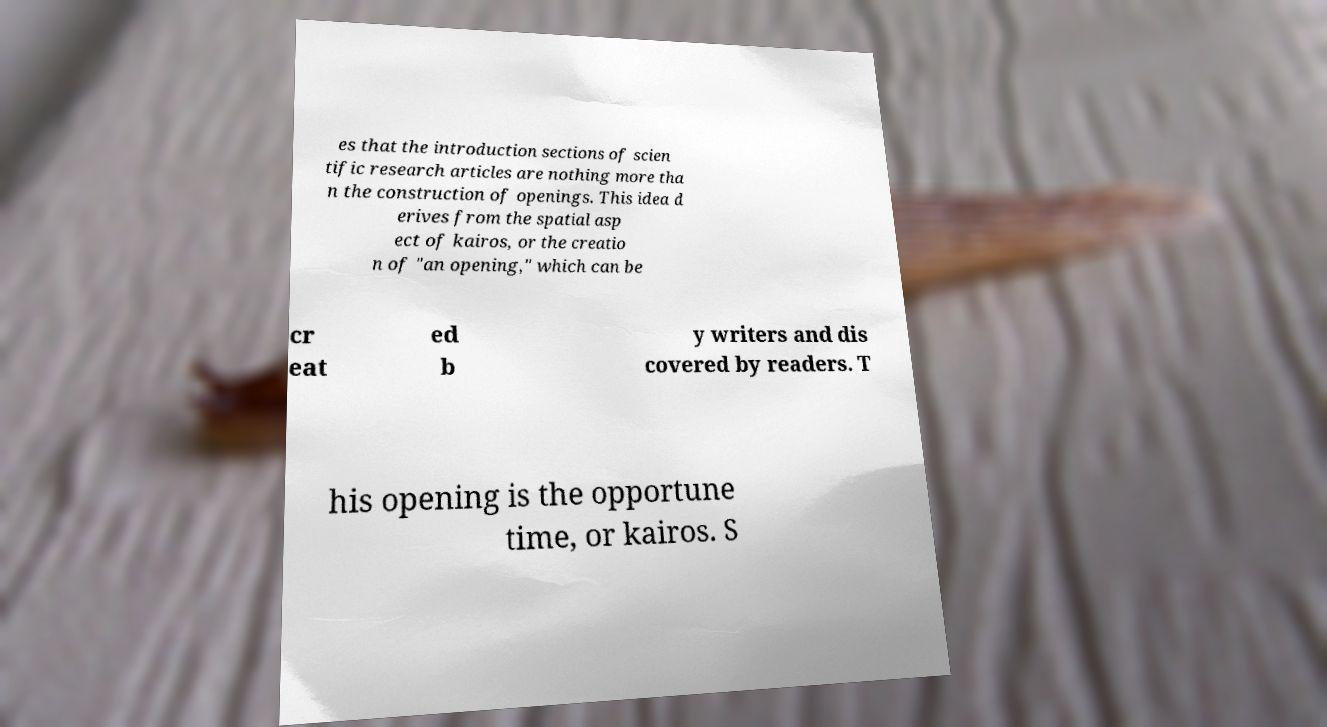Can you read and provide the text displayed in the image?This photo seems to have some interesting text. Can you extract and type it out for me? es that the introduction sections of scien tific research articles are nothing more tha n the construction of openings. This idea d erives from the spatial asp ect of kairos, or the creatio n of "an opening," which can be cr eat ed b y writers and dis covered by readers. T his opening is the opportune time, or kairos. S 